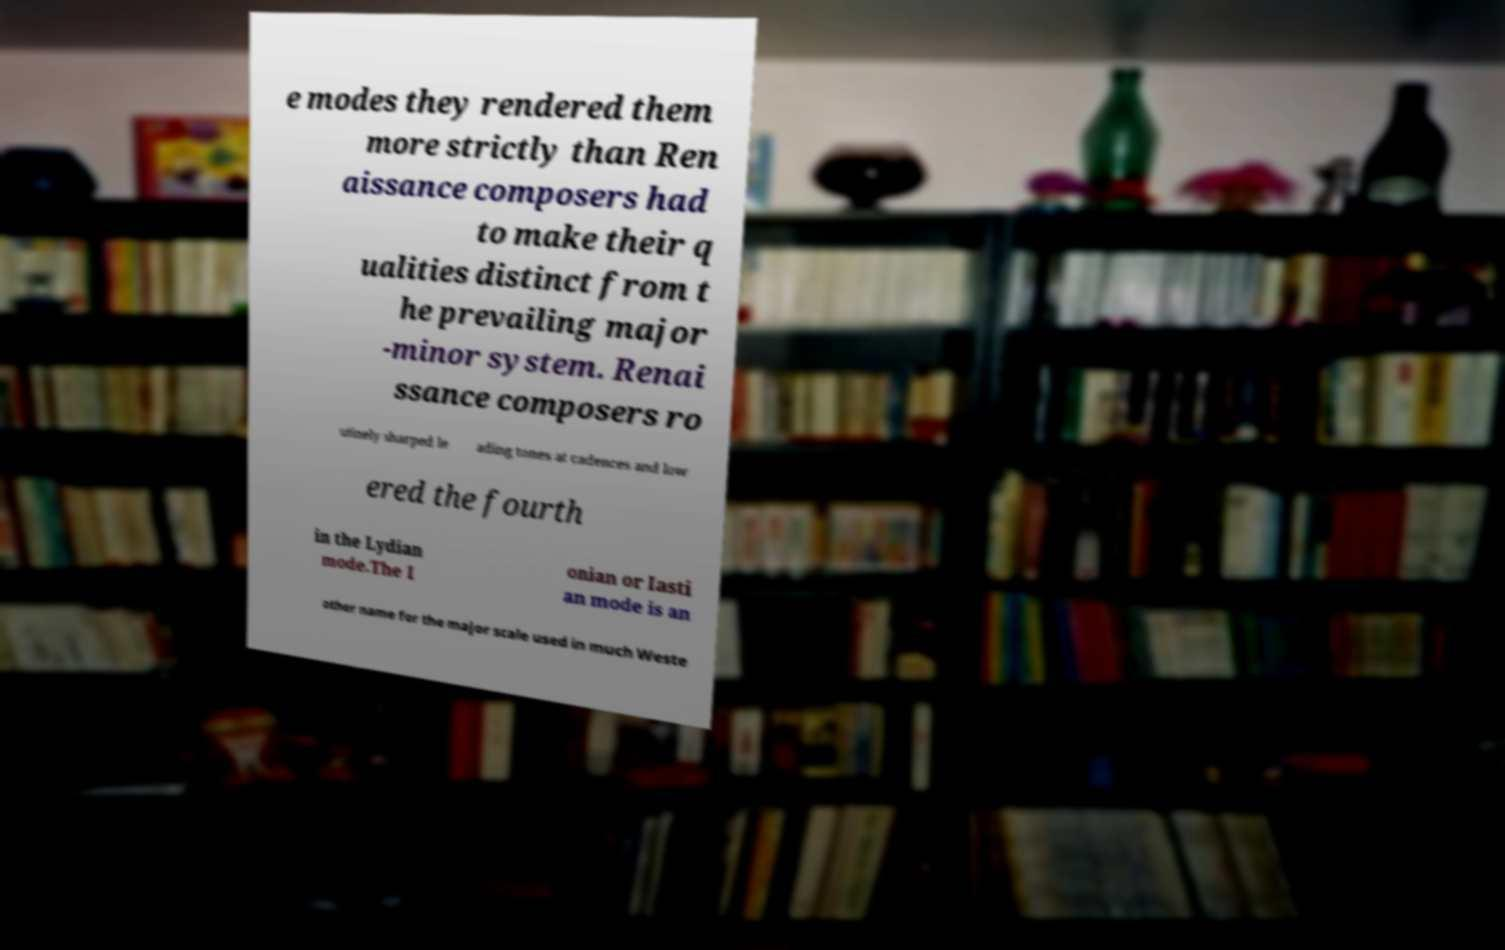Could you assist in decoding the text presented in this image and type it out clearly? e modes they rendered them more strictly than Ren aissance composers had to make their q ualities distinct from t he prevailing major -minor system. Renai ssance composers ro utinely sharped le ading tones at cadences and low ered the fourth in the Lydian mode.The I onian or Iasti an mode is an other name for the major scale used in much Weste 